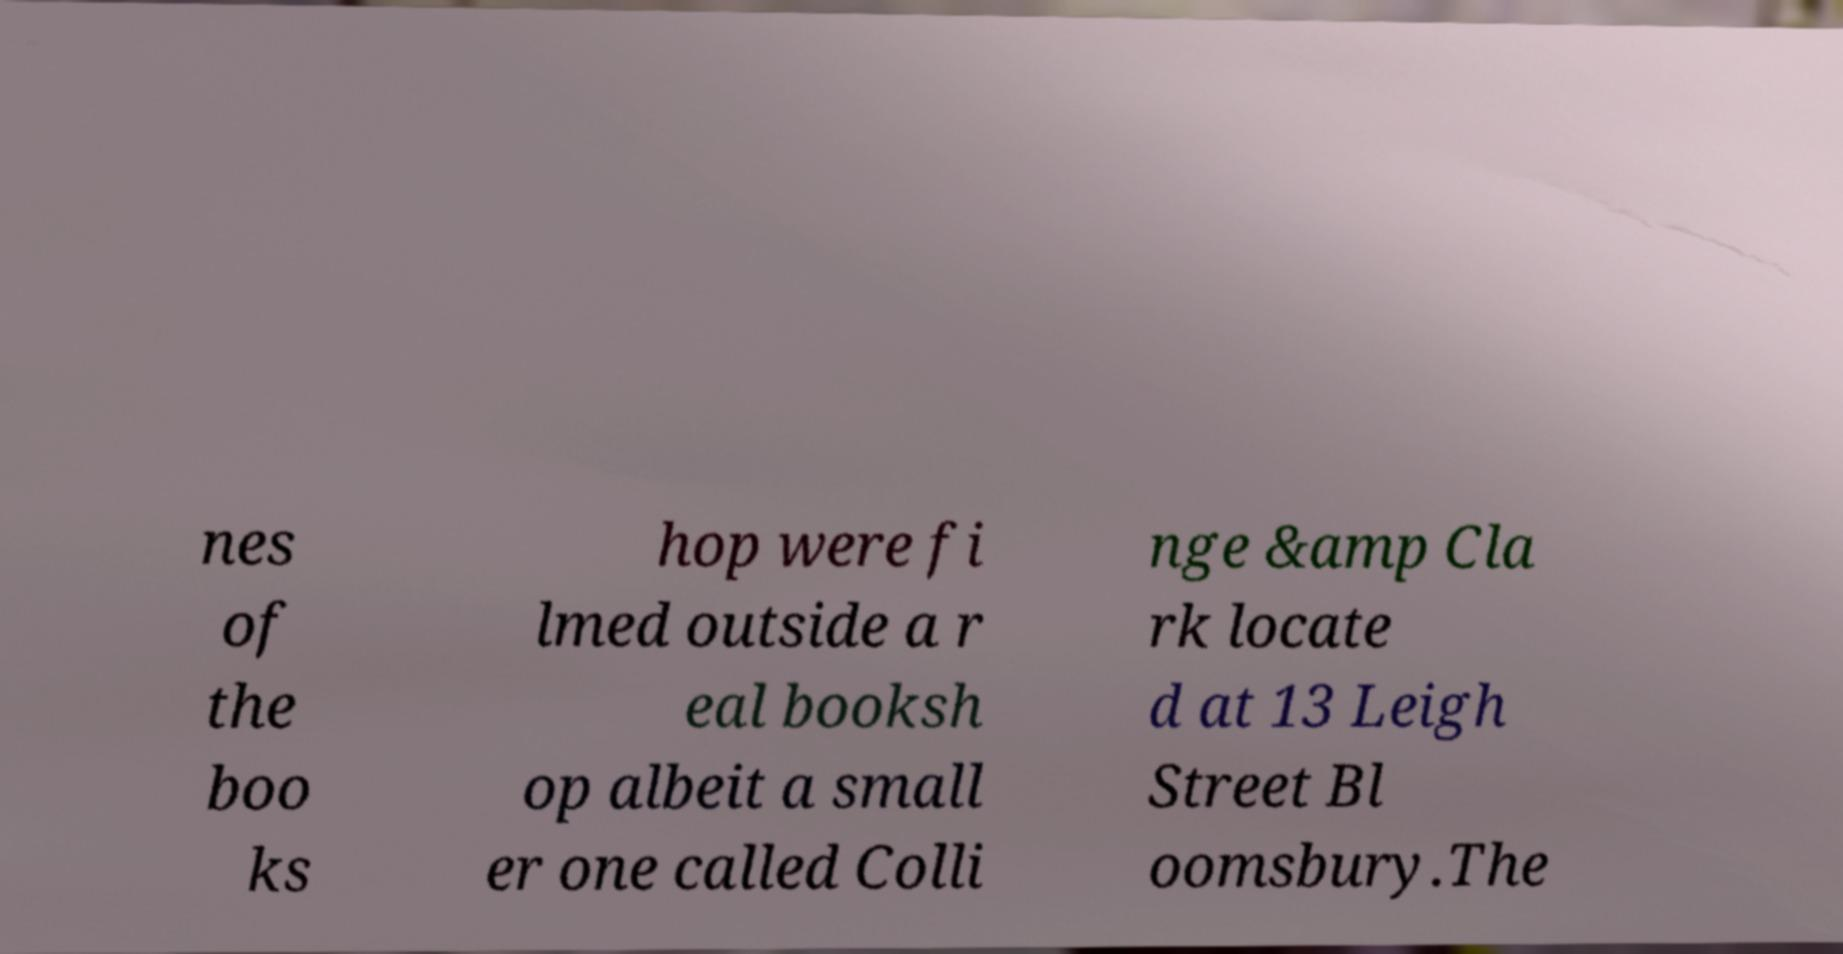Please read and relay the text visible in this image. What does it say? nes of the boo ks hop were fi lmed outside a r eal booksh op albeit a small er one called Colli nge &amp Cla rk locate d at 13 Leigh Street Bl oomsbury.The 